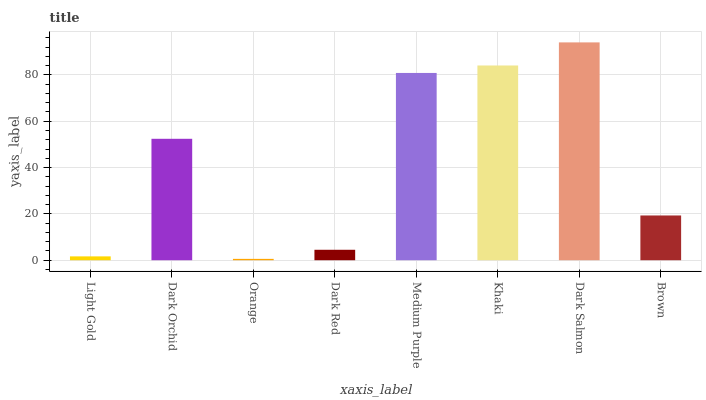Is Orange the minimum?
Answer yes or no. Yes. Is Dark Salmon the maximum?
Answer yes or no. Yes. Is Dark Orchid the minimum?
Answer yes or no. No. Is Dark Orchid the maximum?
Answer yes or no. No. Is Dark Orchid greater than Light Gold?
Answer yes or no. Yes. Is Light Gold less than Dark Orchid?
Answer yes or no. Yes. Is Light Gold greater than Dark Orchid?
Answer yes or no. No. Is Dark Orchid less than Light Gold?
Answer yes or no. No. Is Dark Orchid the high median?
Answer yes or no. Yes. Is Brown the low median?
Answer yes or no. Yes. Is Orange the high median?
Answer yes or no. No. Is Dark Orchid the low median?
Answer yes or no. No. 